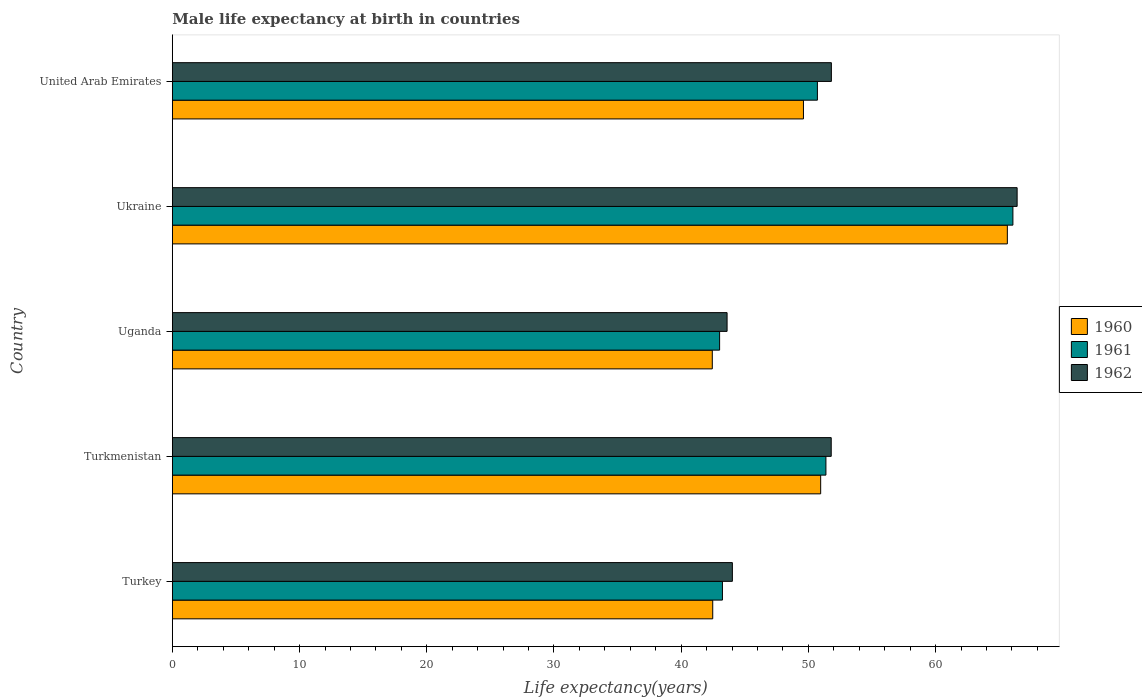How many bars are there on the 3rd tick from the bottom?
Provide a succinct answer. 3. What is the label of the 3rd group of bars from the top?
Give a very brief answer. Uganda. What is the male life expectancy at birth in 1960 in Ukraine?
Give a very brief answer. 65.64. Across all countries, what is the maximum male life expectancy at birth in 1961?
Offer a very short reply. 66.08. Across all countries, what is the minimum male life expectancy at birth in 1960?
Provide a short and direct response. 42.45. In which country was the male life expectancy at birth in 1962 maximum?
Your answer should be very brief. Ukraine. In which country was the male life expectancy at birth in 1962 minimum?
Ensure brevity in your answer.  Uganda. What is the total male life expectancy at birth in 1962 in the graph?
Keep it short and to the point. 257.65. What is the difference between the male life expectancy at birth in 1962 in Turkmenistan and that in Uganda?
Keep it short and to the point. 8.19. What is the difference between the male life expectancy at birth in 1960 in Ukraine and the male life expectancy at birth in 1961 in United Arab Emirates?
Give a very brief answer. 14.93. What is the average male life expectancy at birth in 1961 per country?
Your response must be concise. 50.89. What is the difference between the male life expectancy at birth in 1961 and male life expectancy at birth in 1962 in Turkmenistan?
Make the answer very short. -0.42. What is the ratio of the male life expectancy at birth in 1960 in Turkey to that in Ukraine?
Keep it short and to the point. 0.65. Is the male life expectancy at birth in 1960 in Turkmenistan less than that in Ukraine?
Provide a short and direct response. Yes. What is the difference between the highest and the second highest male life expectancy at birth in 1961?
Your answer should be compact. 14.7. What is the difference between the highest and the lowest male life expectancy at birth in 1962?
Make the answer very short. 22.8. In how many countries, is the male life expectancy at birth in 1960 greater than the average male life expectancy at birth in 1960 taken over all countries?
Offer a terse response. 2. What does the 2nd bar from the bottom in Turkmenistan represents?
Your answer should be very brief. 1961. How many bars are there?
Keep it short and to the point. 15. Are all the bars in the graph horizontal?
Your answer should be compact. Yes. How many countries are there in the graph?
Your answer should be compact. 5. Does the graph contain grids?
Keep it short and to the point. No. What is the title of the graph?
Offer a very short reply. Male life expectancy at birth in countries. Does "2001" appear as one of the legend labels in the graph?
Ensure brevity in your answer.  No. What is the label or title of the X-axis?
Ensure brevity in your answer.  Life expectancy(years). What is the Life expectancy(years) in 1960 in Turkey?
Your response must be concise. 42.48. What is the Life expectancy(years) in 1961 in Turkey?
Provide a short and direct response. 43.24. What is the Life expectancy(years) in 1962 in Turkey?
Offer a very short reply. 44.02. What is the Life expectancy(years) of 1960 in Turkmenistan?
Keep it short and to the point. 50.97. What is the Life expectancy(years) in 1961 in Turkmenistan?
Your response must be concise. 51.38. What is the Life expectancy(years) of 1962 in Turkmenistan?
Your answer should be very brief. 51.8. What is the Life expectancy(years) of 1960 in Uganda?
Your answer should be very brief. 42.45. What is the Life expectancy(years) in 1961 in Uganda?
Your answer should be very brief. 43.02. What is the Life expectancy(years) of 1962 in Uganda?
Make the answer very short. 43.61. What is the Life expectancy(years) in 1960 in Ukraine?
Your answer should be compact. 65.64. What is the Life expectancy(years) in 1961 in Ukraine?
Provide a short and direct response. 66.08. What is the Life expectancy(years) of 1962 in Ukraine?
Your answer should be very brief. 66.41. What is the Life expectancy(years) in 1960 in United Arab Emirates?
Make the answer very short. 49.61. What is the Life expectancy(years) of 1961 in United Arab Emirates?
Ensure brevity in your answer.  50.71. What is the Life expectancy(years) of 1962 in United Arab Emirates?
Make the answer very short. 51.81. Across all countries, what is the maximum Life expectancy(years) of 1960?
Ensure brevity in your answer.  65.64. Across all countries, what is the maximum Life expectancy(years) of 1961?
Your answer should be compact. 66.08. Across all countries, what is the maximum Life expectancy(years) of 1962?
Ensure brevity in your answer.  66.41. Across all countries, what is the minimum Life expectancy(years) of 1960?
Ensure brevity in your answer.  42.45. Across all countries, what is the minimum Life expectancy(years) in 1961?
Offer a very short reply. 43.02. Across all countries, what is the minimum Life expectancy(years) of 1962?
Ensure brevity in your answer.  43.61. What is the total Life expectancy(years) of 1960 in the graph?
Offer a terse response. 251.15. What is the total Life expectancy(years) in 1961 in the graph?
Offer a very short reply. 254.43. What is the total Life expectancy(years) of 1962 in the graph?
Give a very brief answer. 257.65. What is the difference between the Life expectancy(years) in 1960 in Turkey and that in Turkmenistan?
Make the answer very short. -8.48. What is the difference between the Life expectancy(years) of 1961 in Turkey and that in Turkmenistan?
Offer a very short reply. -8.13. What is the difference between the Life expectancy(years) of 1962 in Turkey and that in Turkmenistan?
Ensure brevity in your answer.  -7.77. What is the difference between the Life expectancy(years) of 1960 in Turkey and that in Uganda?
Offer a very short reply. 0.04. What is the difference between the Life expectancy(years) in 1961 in Turkey and that in Uganda?
Your response must be concise. 0.22. What is the difference between the Life expectancy(years) of 1962 in Turkey and that in Uganda?
Your response must be concise. 0.42. What is the difference between the Life expectancy(years) in 1960 in Turkey and that in Ukraine?
Make the answer very short. -23.16. What is the difference between the Life expectancy(years) of 1961 in Turkey and that in Ukraine?
Your response must be concise. -22.83. What is the difference between the Life expectancy(years) of 1962 in Turkey and that in Ukraine?
Give a very brief answer. -22.39. What is the difference between the Life expectancy(years) of 1960 in Turkey and that in United Arab Emirates?
Your answer should be compact. -7.13. What is the difference between the Life expectancy(years) in 1961 in Turkey and that in United Arab Emirates?
Offer a very short reply. -7.46. What is the difference between the Life expectancy(years) in 1962 in Turkey and that in United Arab Emirates?
Your answer should be compact. -7.78. What is the difference between the Life expectancy(years) in 1960 in Turkmenistan and that in Uganda?
Provide a succinct answer. 8.52. What is the difference between the Life expectancy(years) in 1961 in Turkmenistan and that in Uganda?
Provide a short and direct response. 8.36. What is the difference between the Life expectancy(years) of 1962 in Turkmenistan and that in Uganda?
Provide a succinct answer. 8.19. What is the difference between the Life expectancy(years) in 1960 in Turkmenistan and that in Ukraine?
Offer a terse response. -14.68. What is the difference between the Life expectancy(years) in 1961 in Turkmenistan and that in Ukraine?
Give a very brief answer. -14.7. What is the difference between the Life expectancy(years) in 1962 in Turkmenistan and that in Ukraine?
Ensure brevity in your answer.  -14.62. What is the difference between the Life expectancy(years) of 1960 in Turkmenistan and that in United Arab Emirates?
Make the answer very short. 1.35. What is the difference between the Life expectancy(years) in 1961 in Turkmenistan and that in United Arab Emirates?
Offer a terse response. 0.67. What is the difference between the Life expectancy(years) of 1962 in Turkmenistan and that in United Arab Emirates?
Offer a very short reply. -0.01. What is the difference between the Life expectancy(years) in 1960 in Uganda and that in Ukraine?
Provide a short and direct response. -23.2. What is the difference between the Life expectancy(years) in 1961 in Uganda and that in Ukraine?
Offer a very short reply. -23.06. What is the difference between the Life expectancy(years) in 1962 in Uganda and that in Ukraine?
Give a very brief answer. -22.8. What is the difference between the Life expectancy(years) of 1960 in Uganda and that in United Arab Emirates?
Your answer should be very brief. -7.17. What is the difference between the Life expectancy(years) of 1961 in Uganda and that in United Arab Emirates?
Your answer should be compact. -7.69. What is the difference between the Life expectancy(years) in 1962 in Uganda and that in United Arab Emirates?
Give a very brief answer. -8.2. What is the difference between the Life expectancy(years) of 1960 in Ukraine and that in United Arab Emirates?
Ensure brevity in your answer.  16.03. What is the difference between the Life expectancy(years) in 1961 in Ukraine and that in United Arab Emirates?
Offer a terse response. 15.37. What is the difference between the Life expectancy(years) in 1962 in Ukraine and that in United Arab Emirates?
Provide a succinct answer. 14.6. What is the difference between the Life expectancy(years) in 1960 in Turkey and the Life expectancy(years) in 1961 in Turkmenistan?
Your response must be concise. -8.9. What is the difference between the Life expectancy(years) of 1960 in Turkey and the Life expectancy(years) of 1962 in Turkmenistan?
Make the answer very short. -9.31. What is the difference between the Life expectancy(years) of 1961 in Turkey and the Life expectancy(years) of 1962 in Turkmenistan?
Provide a succinct answer. -8.55. What is the difference between the Life expectancy(years) of 1960 in Turkey and the Life expectancy(years) of 1961 in Uganda?
Offer a terse response. -0.54. What is the difference between the Life expectancy(years) of 1960 in Turkey and the Life expectancy(years) of 1962 in Uganda?
Provide a short and direct response. -1.13. What is the difference between the Life expectancy(years) in 1961 in Turkey and the Life expectancy(years) in 1962 in Uganda?
Your answer should be compact. -0.36. What is the difference between the Life expectancy(years) in 1960 in Turkey and the Life expectancy(years) in 1961 in Ukraine?
Make the answer very short. -23.6. What is the difference between the Life expectancy(years) in 1960 in Turkey and the Life expectancy(years) in 1962 in Ukraine?
Make the answer very short. -23.93. What is the difference between the Life expectancy(years) in 1961 in Turkey and the Life expectancy(years) in 1962 in Ukraine?
Make the answer very short. -23.17. What is the difference between the Life expectancy(years) in 1960 in Turkey and the Life expectancy(years) in 1961 in United Arab Emirates?
Your answer should be compact. -8.23. What is the difference between the Life expectancy(years) of 1960 in Turkey and the Life expectancy(years) of 1962 in United Arab Emirates?
Ensure brevity in your answer.  -9.33. What is the difference between the Life expectancy(years) in 1961 in Turkey and the Life expectancy(years) in 1962 in United Arab Emirates?
Offer a terse response. -8.56. What is the difference between the Life expectancy(years) of 1960 in Turkmenistan and the Life expectancy(years) of 1961 in Uganda?
Ensure brevity in your answer.  7.95. What is the difference between the Life expectancy(years) in 1960 in Turkmenistan and the Life expectancy(years) in 1962 in Uganda?
Offer a very short reply. 7.36. What is the difference between the Life expectancy(years) of 1961 in Turkmenistan and the Life expectancy(years) of 1962 in Uganda?
Your response must be concise. 7.77. What is the difference between the Life expectancy(years) in 1960 in Turkmenistan and the Life expectancy(years) in 1961 in Ukraine?
Give a very brief answer. -15.11. What is the difference between the Life expectancy(years) in 1960 in Turkmenistan and the Life expectancy(years) in 1962 in Ukraine?
Give a very brief answer. -15.44. What is the difference between the Life expectancy(years) of 1961 in Turkmenistan and the Life expectancy(years) of 1962 in Ukraine?
Make the answer very short. -15.03. What is the difference between the Life expectancy(years) of 1960 in Turkmenistan and the Life expectancy(years) of 1961 in United Arab Emirates?
Provide a short and direct response. 0.26. What is the difference between the Life expectancy(years) in 1960 in Turkmenistan and the Life expectancy(years) in 1962 in United Arab Emirates?
Offer a very short reply. -0.84. What is the difference between the Life expectancy(years) of 1961 in Turkmenistan and the Life expectancy(years) of 1962 in United Arab Emirates?
Your response must be concise. -0.43. What is the difference between the Life expectancy(years) of 1960 in Uganda and the Life expectancy(years) of 1961 in Ukraine?
Provide a short and direct response. -23.63. What is the difference between the Life expectancy(years) of 1960 in Uganda and the Life expectancy(years) of 1962 in Ukraine?
Give a very brief answer. -23.96. What is the difference between the Life expectancy(years) in 1961 in Uganda and the Life expectancy(years) in 1962 in Ukraine?
Give a very brief answer. -23.39. What is the difference between the Life expectancy(years) of 1960 in Uganda and the Life expectancy(years) of 1961 in United Arab Emirates?
Your answer should be very brief. -8.26. What is the difference between the Life expectancy(years) of 1960 in Uganda and the Life expectancy(years) of 1962 in United Arab Emirates?
Your answer should be very brief. -9.36. What is the difference between the Life expectancy(years) in 1961 in Uganda and the Life expectancy(years) in 1962 in United Arab Emirates?
Offer a very short reply. -8.79. What is the difference between the Life expectancy(years) in 1960 in Ukraine and the Life expectancy(years) in 1961 in United Arab Emirates?
Ensure brevity in your answer.  14.93. What is the difference between the Life expectancy(years) of 1960 in Ukraine and the Life expectancy(years) of 1962 in United Arab Emirates?
Offer a very short reply. 13.83. What is the difference between the Life expectancy(years) in 1961 in Ukraine and the Life expectancy(years) in 1962 in United Arab Emirates?
Your response must be concise. 14.27. What is the average Life expectancy(years) in 1960 per country?
Offer a terse response. 50.23. What is the average Life expectancy(years) of 1961 per country?
Provide a short and direct response. 50.89. What is the average Life expectancy(years) in 1962 per country?
Give a very brief answer. 51.53. What is the difference between the Life expectancy(years) of 1960 and Life expectancy(years) of 1961 in Turkey?
Provide a short and direct response. -0.76. What is the difference between the Life expectancy(years) in 1960 and Life expectancy(years) in 1962 in Turkey?
Your answer should be compact. -1.54. What is the difference between the Life expectancy(years) of 1961 and Life expectancy(years) of 1962 in Turkey?
Your answer should be very brief. -0.78. What is the difference between the Life expectancy(years) of 1960 and Life expectancy(years) of 1961 in Turkmenistan?
Ensure brevity in your answer.  -0.41. What is the difference between the Life expectancy(years) in 1960 and Life expectancy(years) in 1962 in Turkmenistan?
Offer a very short reply. -0.83. What is the difference between the Life expectancy(years) in 1961 and Life expectancy(years) in 1962 in Turkmenistan?
Give a very brief answer. -0.42. What is the difference between the Life expectancy(years) in 1960 and Life expectancy(years) in 1961 in Uganda?
Offer a terse response. -0.57. What is the difference between the Life expectancy(years) of 1960 and Life expectancy(years) of 1962 in Uganda?
Ensure brevity in your answer.  -1.16. What is the difference between the Life expectancy(years) in 1961 and Life expectancy(years) in 1962 in Uganda?
Ensure brevity in your answer.  -0.59. What is the difference between the Life expectancy(years) in 1960 and Life expectancy(years) in 1961 in Ukraine?
Offer a terse response. -0.44. What is the difference between the Life expectancy(years) of 1960 and Life expectancy(years) of 1962 in Ukraine?
Give a very brief answer. -0.77. What is the difference between the Life expectancy(years) of 1961 and Life expectancy(years) of 1962 in Ukraine?
Ensure brevity in your answer.  -0.33. What is the difference between the Life expectancy(years) in 1960 and Life expectancy(years) in 1961 in United Arab Emirates?
Offer a terse response. -1.1. What is the difference between the Life expectancy(years) of 1960 and Life expectancy(years) of 1962 in United Arab Emirates?
Offer a very short reply. -2.19. What is the difference between the Life expectancy(years) of 1961 and Life expectancy(years) of 1962 in United Arab Emirates?
Keep it short and to the point. -1.1. What is the ratio of the Life expectancy(years) in 1960 in Turkey to that in Turkmenistan?
Provide a short and direct response. 0.83. What is the ratio of the Life expectancy(years) in 1961 in Turkey to that in Turkmenistan?
Provide a succinct answer. 0.84. What is the ratio of the Life expectancy(years) in 1960 in Turkey to that in Uganda?
Keep it short and to the point. 1. What is the ratio of the Life expectancy(years) of 1962 in Turkey to that in Uganda?
Ensure brevity in your answer.  1.01. What is the ratio of the Life expectancy(years) in 1960 in Turkey to that in Ukraine?
Your response must be concise. 0.65. What is the ratio of the Life expectancy(years) in 1961 in Turkey to that in Ukraine?
Offer a terse response. 0.65. What is the ratio of the Life expectancy(years) in 1962 in Turkey to that in Ukraine?
Make the answer very short. 0.66. What is the ratio of the Life expectancy(years) in 1960 in Turkey to that in United Arab Emirates?
Your answer should be very brief. 0.86. What is the ratio of the Life expectancy(years) of 1961 in Turkey to that in United Arab Emirates?
Provide a short and direct response. 0.85. What is the ratio of the Life expectancy(years) in 1962 in Turkey to that in United Arab Emirates?
Make the answer very short. 0.85. What is the ratio of the Life expectancy(years) in 1960 in Turkmenistan to that in Uganda?
Your answer should be very brief. 1.2. What is the ratio of the Life expectancy(years) in 1961 in Turkmenistan to that in Uganda?
Your answer should be very brief. 1.19. What is the ratio of the Life expectancy(years) of 1962 in Turkmenistan to that in Uganda?
Give a very brief answer. 1.19. What is the ratio of the Life expectancy(years) in 1960 in Turkmenistan to that in Ukraine?
Ensure brevity in your answer.  0.78. What is the ratio of the Life expectancy(years) of 1961 in Turkmenistan to that in Ukraine?
Keep it short and to the point. 0.78. What is the ratio of the Life expectancy(years) in 1962 in Turkmenistan to that in Ukraine?
Offer a terse response. 0.78. What is the ratio of the Life expectancy(years) in 1960 in Turkmenistan to that in United Arab Emirates?
Your response must be concise. 1.03. What is the ratio of the Life expectancy(years) of 1961 in Turkmenistan to that in United Arab Emirates?
Your answer should be very brief. 1.01. What is the ratio of the Life expectancy(years) of 1962 in Turkmenistan to that in United Arab Emirates?
Your response must be concise. 1. What is the ratio of the Life expectancy(years) in 1960 in Uganda to that in Ukraine?
Offer a terse response. 0.65. What is the ratio of the Life expectancy(years) of 1961 in Uganda to that in Ukraine?
Make the answer very short. 0.65. What is the ratio of the Life expectancy(years) of 1962 in Uganda to that in Ukraine?
Your answer should be very brief. 0.66. What is the ratio of the Life expectancy(years) of 1960 in Uganda to that in United Arab Emirates?
Your response must be concise. 0.86. What is the ratio of the Life expectancy(years) in 1961 in Uganda to that in United Arab Emirates?
Keep it short and to the point. 0.85. What is the ratio of the Life expectancy(years) of 1962 in Uganda to that in United Arab Emirates?
Provide a short and direct response. 0.84. What is the ratio of the Life expectancy(years) in 1960 in Ukraine to that in United Arab Emirates?
Provide a short and direct response. 1.32. What is the ratio of the Life expectancy(years) in 1961 in Ukraine to that in United Arab Emirates?
Provide a succinct answer. 1.3. What is the ratio of the Life expectancy(years) of 1962 in Ukraine to that in United Arab Emirates?
Your response must be concise. 1.28. What is the difference between the highest and the second highest Life expectancy(years) of 1960?
Your answer should be very brief. 14.68. What is the difference between the highest and the second highest Life expectancy(years) of 1961?
Make the answer very short. 14.7. What is the difference between the highest and the second highest Life expectancy(years) in 1962?
Provide a succinct answer. 14.6. What is the difference between the highest and the lowest Life expectancy(years) in 1960?
Your answer should be very brief. 23.2. What is the difference between the highest and the lowest Life expectancy(years) of 1961?
Give a very brief answer. 23.06. What is the difference between the highest and the lowest Life expectancy(years) in 1962?
Your response must be concise. 22.8. 